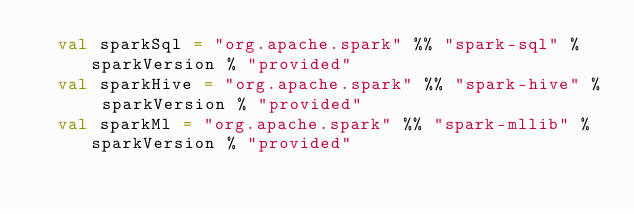<code> <loc_0><loc_0><loc_500><loc_500><_Scala_>  val sparkSql = "org.apache.spark" %% "spark-sql" % sparkVersion % "provided"
  val sparkHive = "org.apache.spark" %% "spark-hive" % sparkVersion % "provided"
  val sparkMl = "org.apache.spark" %% "spark-mllib" % sparkVersion % "provided"
</code> 